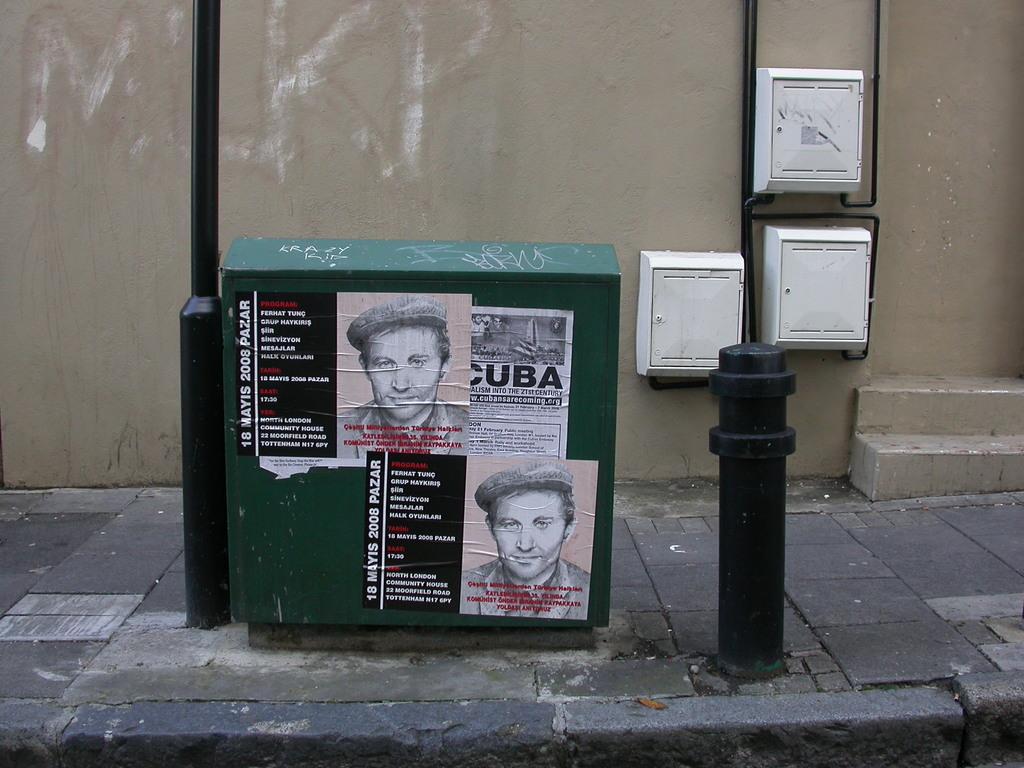Can you describe this image briefly? There are posters that are attached to the green color box. On the right side it is the pole and this is the wall. 